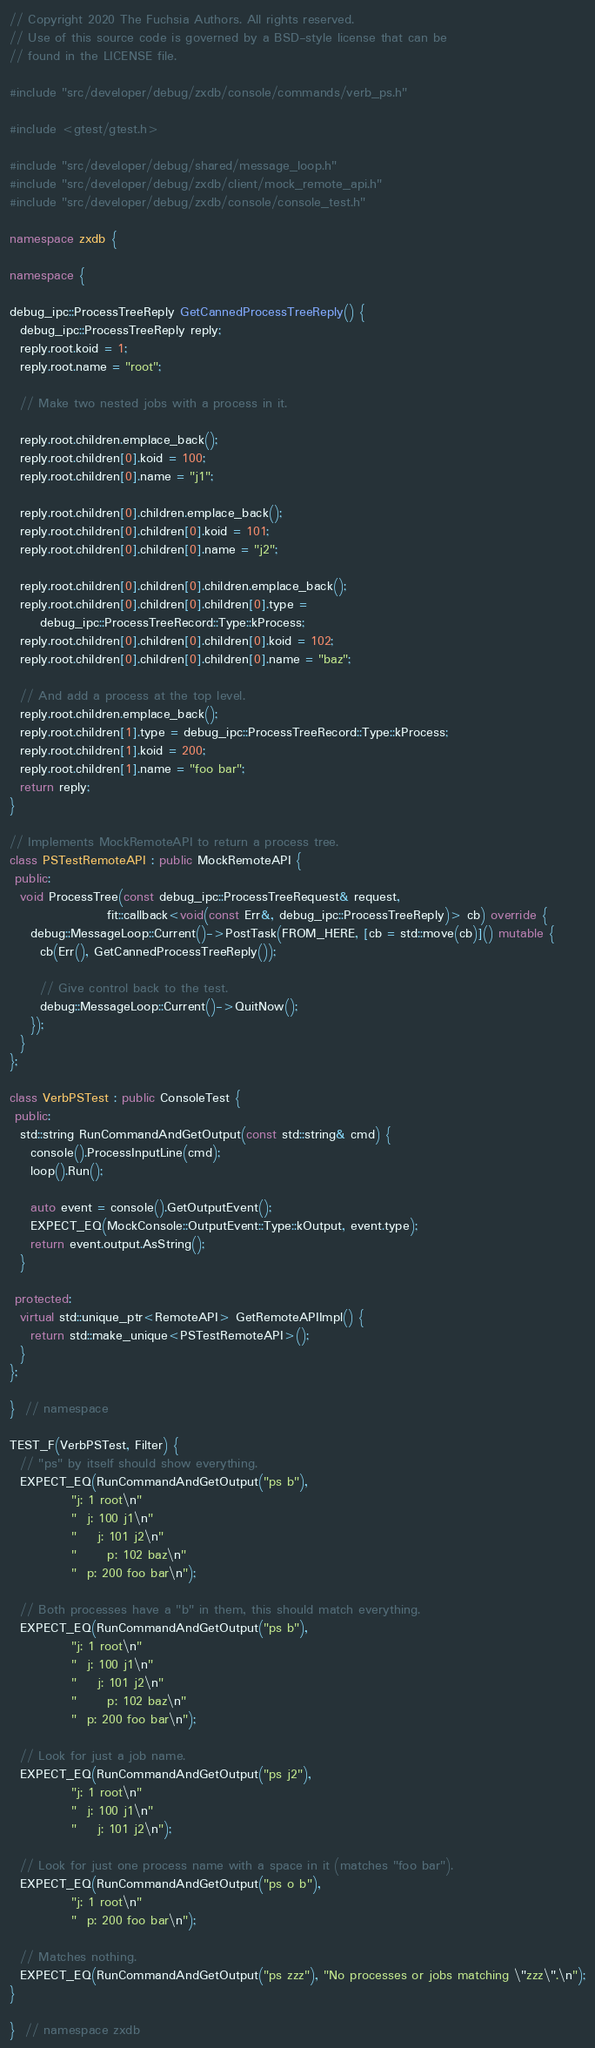Convert code to text. <code><loc_0><loc_0><loc_500><loc_500><_C++_>// Copyright 2020 The Fuchsia Authors. All rights reserved.
// Use of this source code is governed by a BSD-style license that can be
// found in the LICENSE file.

#include "src/developer/debug/zxdb/console/commands/verb_ps.h"

#include <gtest/gtest.h>

#include "src/developer/debug/shared/message_loop.h"
#include "src/developer/debug/zxdb/client/mock_remote_api.h"
#include "src/developer/debug/zxdb/console/console_test.h"

namespace zxdb {

namespace {

debug_ipc::ProcessTreeReply GetCannedProcessTreeReply() {
  debug_ipc::ProcessTreeReply reply;
  reply.root.koid = 1;
  reply.root.name = "root";

  // Make two nested jobs with a process in it.

  reply.root.children.emplace_back();
  reply.root.children[0].koid = 100;
  reply.root.children[0].name = "j1";

  reply.root.children[0].children.emplace_back();
  reply.root.children[0].children[0].koid = 101;
  reply.root.children[0].children[0].name = "j2";

  reply.root.children[0].children[0].children.emplace_back();
  reply.root.children[0].children[0].children[0].type =
      debug_ipc::ProcessTreeRecord::Type::kProcess;
  reply.root.children[0].children[0].children[0].koid = 102;
  reply.root.children[0].children[0].children[0].name = "baz";

  // And add a process at the top level.
  reply.root.children.emplace_back();
  reply.root.children[1].type = debug_ipc::ProcessTreeRecord::Type::kProcess;
  reply.root.children[1].koid = 200;
  reply.root.children[1].name = "foo bar";
  return reply;
}

// Implements MockRemoteAPI to return a process tree.
class PSTestRemoteAPI : public MockRemoteAPI {
 public:
  void ProcessTree(const debug_ipc::ProcessTreeRequest& request,
                   fit::callback<void(const Err&, debug_ipc::ProcessTreeReply)> cb) override {
    debug::MessageLoop::Current()->PostTask(FROM_HERE, [cb = std::move(cb)]() mutable {
      cb(Err(), GetCannedProcessTreeReply());

      // Give control back to the test.
      debug::MessageLoop::Current()->QuitNow();
    });
  }
};

class VerbPSTest : public ConsoleTest {
 public:
  std::string RunCommandAndGetOutput(const std::string& cmd) {
    console().ProcessInputLine(cmd);
    loop().Run();

    auto event = console().GetOutputEvent();
    EXPECT_EQ(MockConsole::OutputEvent::Type::kOutput, event.type);
    return event.output.AsString();
  }

 protected:
  virtual std::unique_ptr<RemoteAPI> GetRemoteAPIImpl() {
    return std::make_unique<PSTestRemoteAPI>();
  }
};

}  // namespace

TEST_F(VerbPSTest, Filter) {
  // "ps" by itself should show everything.
  EXPECT_EQ(RunCommandAndGetOutput("ps b"),
            "j: 1 root\n"
            "  j: 100 j1\n"
            "    j: 101 j2\n"
            "      p: 102 baz\n"
            "  p: 200 foo bar\n");

  // Both processes have a "b" in them, this should match everything.
  EXPECT_EQ(RunCommandAndGetOutput("ps b"),
            "j: 1 root\n"
            "  j: 100 j1\n"
            "    j: 101 j2\n"
            "      p: 102 baz\n"
            "  p: 200 foo bar\n");

  // Look for just a job name.
  EXPECT_EQ(RunCommandAndGetOutput("ps j2"),
            "j: 1 root\n"
            "  j: 100 j1\n"
            "    j: 101 j2\n");

  // Look for just one process name with a space in it (matches "foo bar").
  EXPECT_EQ(RunCommandAndGetOutput("ps o b"),
            "j: 1 root\n"
            "  p: 200 foo bar\n");

  // Matches nothing.
  EXPECT_EQ(RunCommandAndGetOutput("ps zzz"), "No processes or jobs matching \"zzz\".\n");
}

}  // namespace zxdb
</code> 